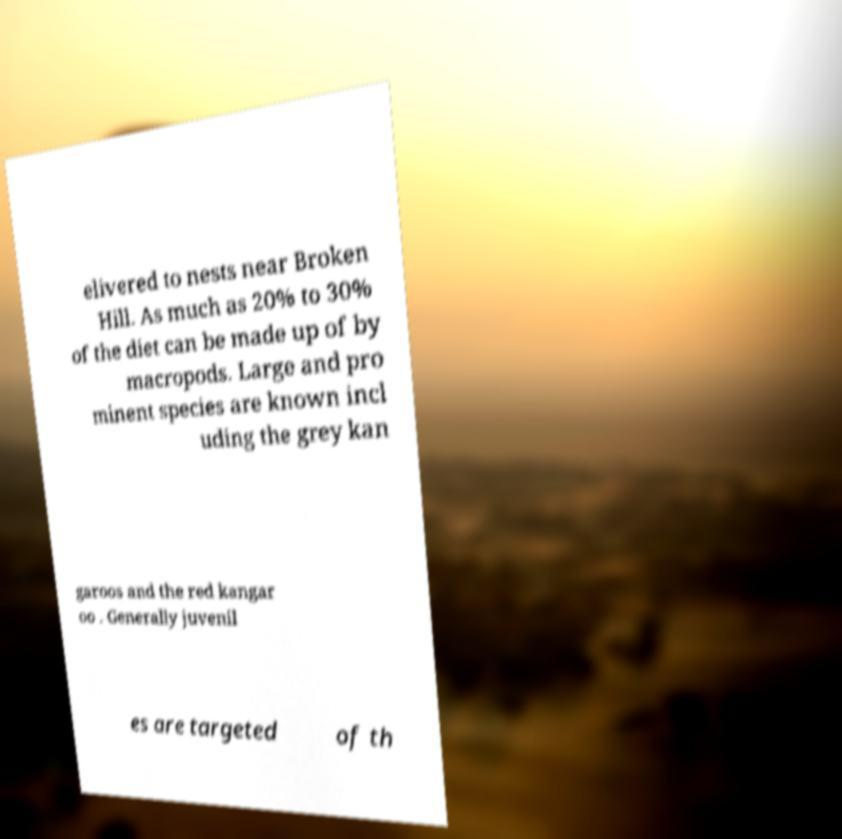For documentation purposes, I need the text within this image transcribed. Could you provide that? elivered to nests near Broken Hill. As much as 20% to 30% of the diet can be made up of by macropods. Large and pro minent species are known incl uding the grey kan garoos and the red kangar oo . Generally juvenil es are targeted of th 